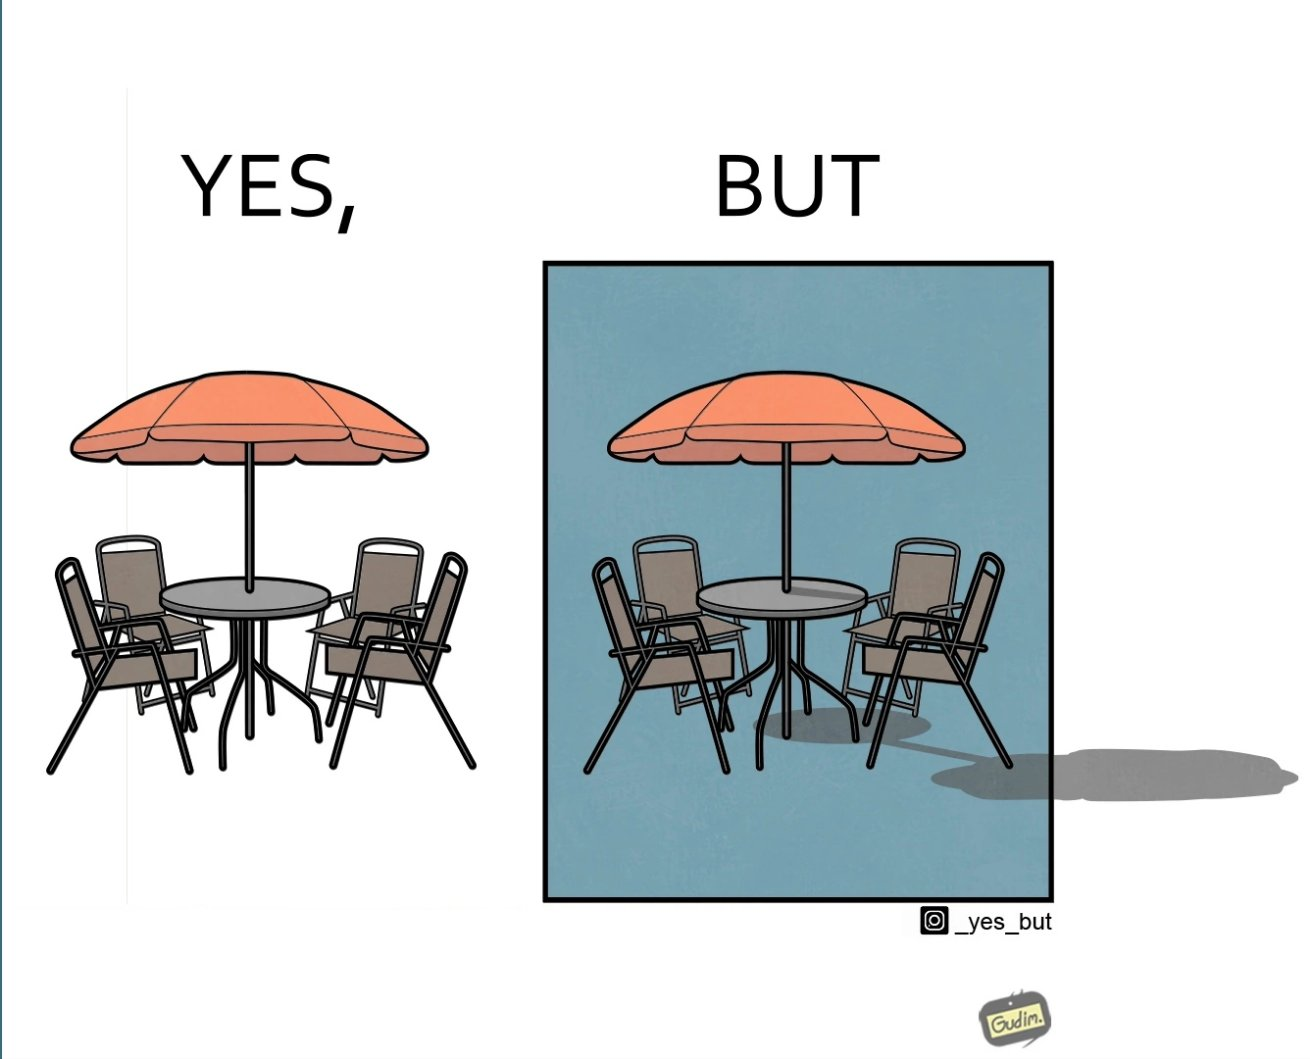Is this image satirical or non-satirical? Yes, this image is satirical. 